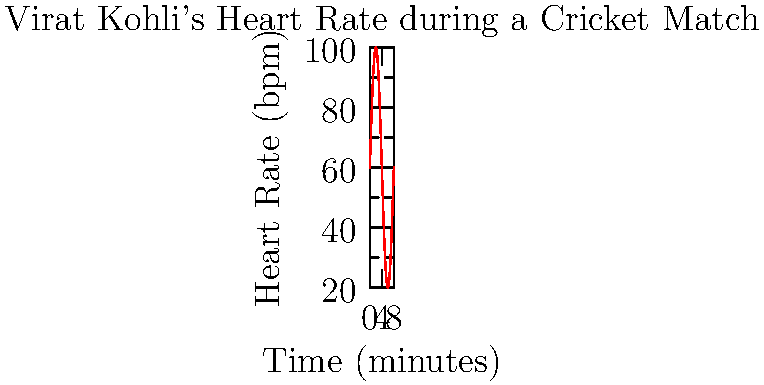During a crucial cricket match, Indian batting legend Virat Kohli's heart rate was monitored and represented by the function $f(t) = 60 + 40\sin(\frac{\pi t}{4})$, where $t$ is the time in minutes and $f(t)$ is the heart rate in beats per minute. Calculate the average heart rate of Kohli during the first 8 minutes of his innings using the concept of the area under the curve. To find the average heart rate, we need to calculate the area under the curve and divide it by the time interval. Let's break it down step-by-step:

1) The area under the curve is given by the definite integral:
   $$A = \int_0^8 (60 + 40\sin(\frac{\pi t}{4})) dt$$

2) Let's solve this integral:
   $$A = [60t - \frac{160}{\pi}\cos(\frac{\pi t}{4})]_0^8$$

3) Evaluating at the limits:
   $$A = (60 \cdot 8 - \frac{160}{\pi}\cos(2\pi)) - (0 - \frac{160}{\pi}\cos(0))$$
   $$A = 480 - \frac{160}{\pi}\cos(2\pi) + \frac{160}{\pi}$$

4) Simplify:
   $$A = 480 + \frac{160}{\pi}(1 - \cos(2\pi)) = 480$$

5) The average heart rate is the area divided by the time interval:
   $$\text{Average Heart Rate} = \frac{A}{8} = \frac{480}{8} = 60 \text{ bpm}$$

Thus, Virat Kohli's average heart rate during the first 8 minutes of his innings was 60 beats per minute.
Answer: 60 bpm 